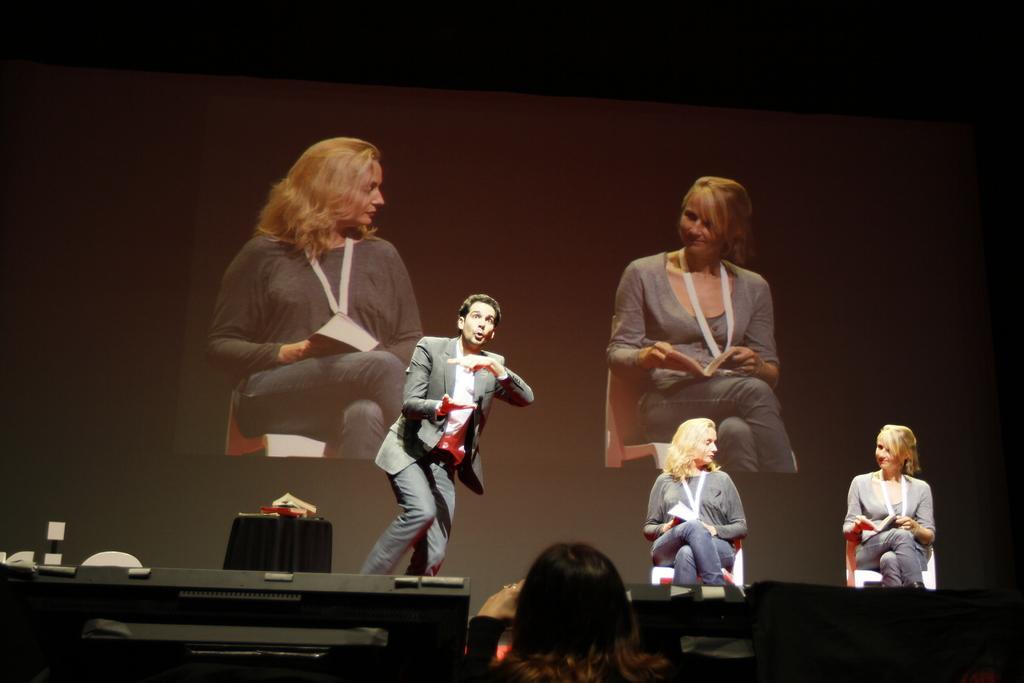How would you summarize this image in a sentence or two? In this picture we can see two women wore id cars and holding books with their hands and sitting on chairs and beside them we can see a man and a table with books on it and in front of them we can see a person and some devices and at the back of them we can see a screen. 